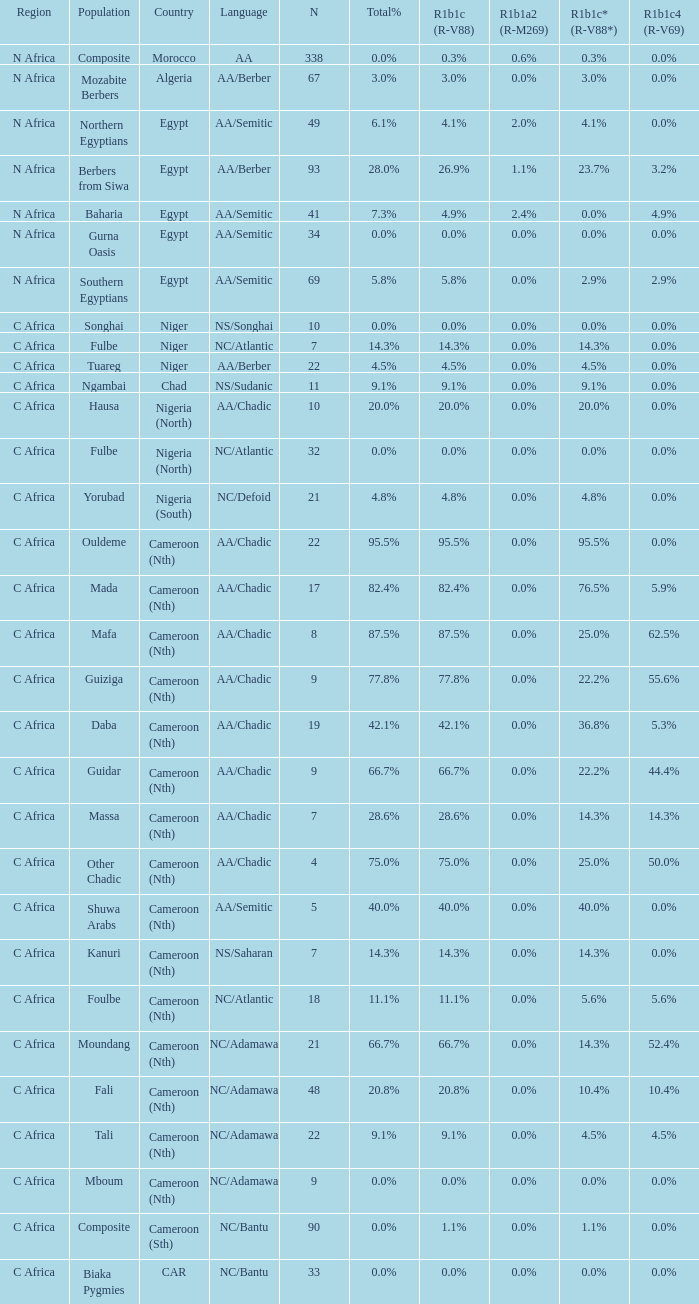What proportion is mentioned in column r1b1c (r-v88) for the 4.5%. 